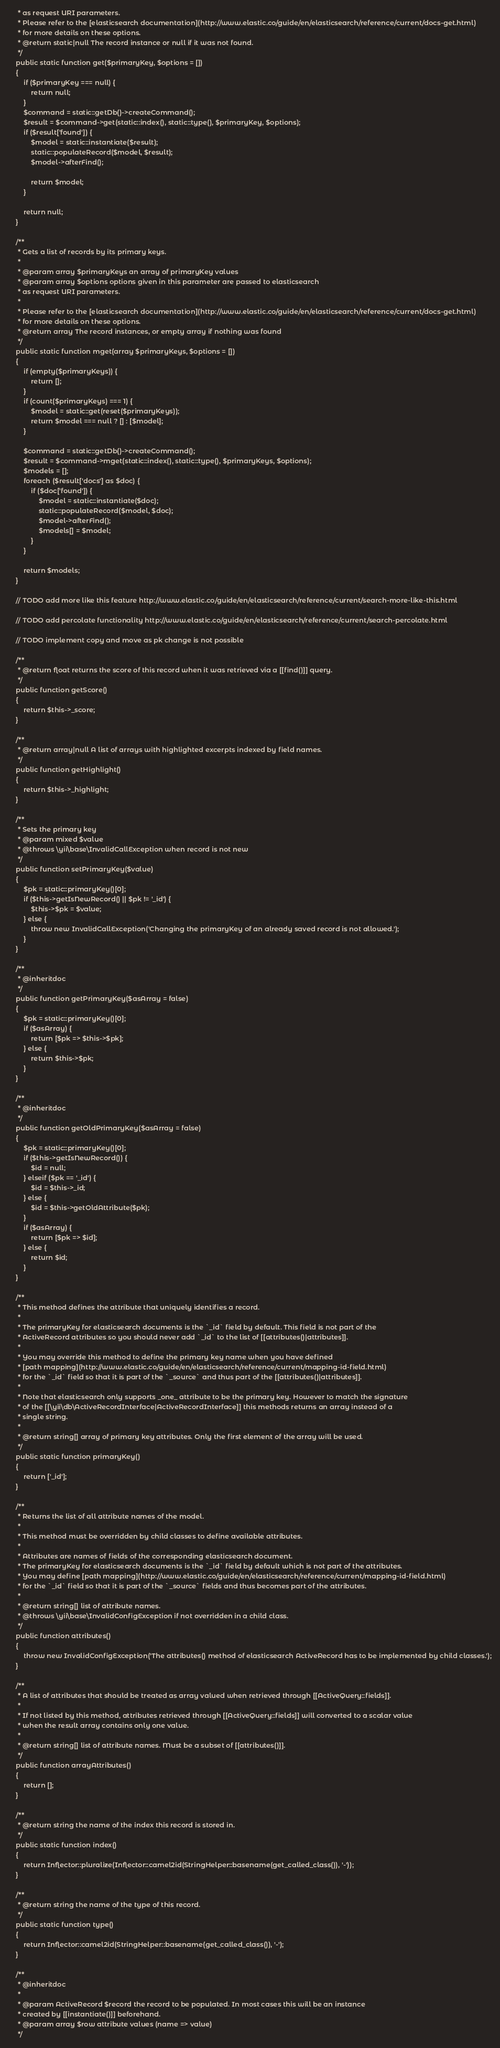<code> <loc_0><loc_0><loc_500><loc_500><_PHP_>     * as request URI parameters.
     * Please refer to the [elasticsearch documentation](http://www.elastic.co/guide/en/elasticsearch/reference/current/docs-get.html)
     * for more details on these options.
     * @return static|null The record instance or null if it was not found.
     */
    public static function get($primaryKey, $options = [])
    {
        if ($primaryKey === null) {
            return null;
        }
        $command = static::getDb()->createCommand();
        $result = $command->get(static::index(), static::type(), $primaryKey, $options);
        if ($result['found']) {
            $model = static::instantiate($result);
            static::populateRecord($model, $result);
            $model->afterFind();

            return $model;
        }

        return null;
    }

    /**
     * Gets a list of records by its primary keys.
     *
     * @param array $primaryKeys an array of primaryKey values
     * @param array $options options given in this parameter are passed to elasticsearch
     * as request URI parameters.
     *
     * Please refer to the [elasticsearch documentation](http://www.elastic.co/guide/en/elasticsearch/reference/current/docs-get.html)
     * for more details on these options.
     * @return array The record instances, or empty array if nothing was found
     */
    public static function mget(array $primaryKeys, $options = [])
    {
        if (empty($primaryKeys)) {
            return [];
        }
        if (count($primaryKeys) === 1) {
            $model = static::get(reset($primaryKeys));
            return $model === null ? [] : [$model];
        }

        $command = static::getDb()->createCommand();
        $result = $command->mget(static::index(), static::type(), $primaryKeys, $options);
        $models = [];
        foreach ($result['docs'] as $doc) {
            if ($doc['found']) {
                $model = static::instantiate($doc);
                static::populateRecord($model, $doc);
                $model->afterFind();
                $models[] = $model;
            }
        }

        return $models;
    }

    // TODO add more like this feature http://www.elastic.co/guide/en/elasticsearch/reference/current/search-more-like-this.html

    // TODO add percolate functionality http://www.elastic.co/guide/en/elasticsearch/reference/current/search-percolate.html

    // TODO implement copy and move as pk change is not possible

    /**
     * @return float returns the score of this record when it was retrieved via a [[find()]] query.
     */
    public function getScore()
    {
        return $this->_score;
    }

    /**
     * @return array|null A list of arrays with highlighted excerpts indexed by field names.
     */
    public function getHighlight()
    {
        return $this->_highlight;
    }

    /**
     * Sets the primary key
     * @param mixed $value
     * @throws \yii\base\InvalidCallException when record is not new
     */
    public function setPrimaryKey($value)
    {
        $pk = static::primaryKey()[0];
        if ($this->getIsNewRecord() || $pk != '_id') {
            $this->$pk = $value;
        } else {
            throw new InvalidCallException('Changing the primaryKey of an already saved record is not allowed.');
        }
    }

    /**
     * @inheritdoc
     */
    public function getPrimaryKey($asArray = false)
    {
        $pk = static::primaryKey()[0];
        if ($asArray) {
            return [$pk => $this->$pk];
        } else {
            return $this->$pk;
        }
    }

    /**
     * @inheritdoc
     */
    public function getOldPrimaryKey($asArray = false)
    {
        $pk = static::primaryKey()[0];
        if ($this->getIsNewRecord()) {
            $id = null;
        } elseif ($pk == '_id') {
            $id = $this->_id;
        } else {
            $id = $this->getOldAttribute($pk);
        }
        if ($asArray) {
            return [$pk => $id];
        } else {
            return $id;
        }
    }

    /**
     * This method defines the attribute that uniquely identifies a record.
     *
     * The primaryKey for elasticsearch documents is the `_id` field by default. This field is not part of the
     * ActiveRecord attributes so you should never add `_id` to the list of [[attributes()|attributes]].
     *
     * You may override this method to define the primary key name when you have defined
     * [path mapping](http://www.elastic.co/guide/en/elasticsearch/reference/current/mapping-id-field.html)
     * for the `_id` field so that it is part of the `_source` and thus part of the [[attributes()|attributes]].
     *
     * Note that elasticsearch only supports _one_ attribute to be the primary key. However to match the signature
     * of the [[\yii\db\ActiveRecordInterface|ActiveRecordInterface]] this methods returns an array instead of a
     * single string.
     *
     * @return string[] array of primary key attributes. Only the first element of the array will be used.
     */
    public static function primaryKey()
    {
        return ['_id'];
    }

    /**
     * Returns the list of all attribute names of the model.
     *
     * This method must be overridden by child classes to define available attributes.
     *
     * Attributes are names of fields of the corresponding elasticsearch document.
     * The primaryKey for elasticsearch documents is the `_id` field by default which is not part of the attributes.
     * You may define [path mapping](http://www.elastic.co/guide/en/elasticsearch/reference/current/mapping-id-field.html)
     * for the `_id` field so that it is part of the `_source` fields and thus becomes part of the attributes.
     *
     * @return string[] list of attribute names.
     * @throws \yii\base\InvalidConfigException if not overridden in a child class.
     */
    public function attributes()
    {
        throw new InvalidConfigException('The attributes() method of elasticsearch ActiveRecord has to be implemented by child classes.');
    }

    /**
     * A list of attributes that should be treated as array valued when retrieved through [[ActiveQuery::fields]].
     *
     * If not listed by this method, attributes retrieved through [[ActiveQuery::fields]] will converted to a scalar value
     * when the result array contains only one value.
     *
     * @return string[] list of attribute names. Must be a subset of [[attributes()]].
     */
    public function arrayAttributes()
    {
        return [];
    }

    /**
     * @return string the name of the index this record is stored in.
     */
    public static function index()
    {
        return Inflector::pluralize(Inflector::camel2id(StringHelper::basename(get_called_class()), '-'));
    }

    /**
     * @return string the name of the type of this record.
     */
    public static function type()
    {
        return Inflector::camel2id(StringHelper::basename(get_called_class()), '-');
    }

    /**
     * @inheritdoc
     *
     * @param ActiveRecord $record the record to be populated. In most cases this will be an instance
     * created by [[instantiate()]] beforehand.
     * @param array $row attribute values (name => value)
     */</code> 